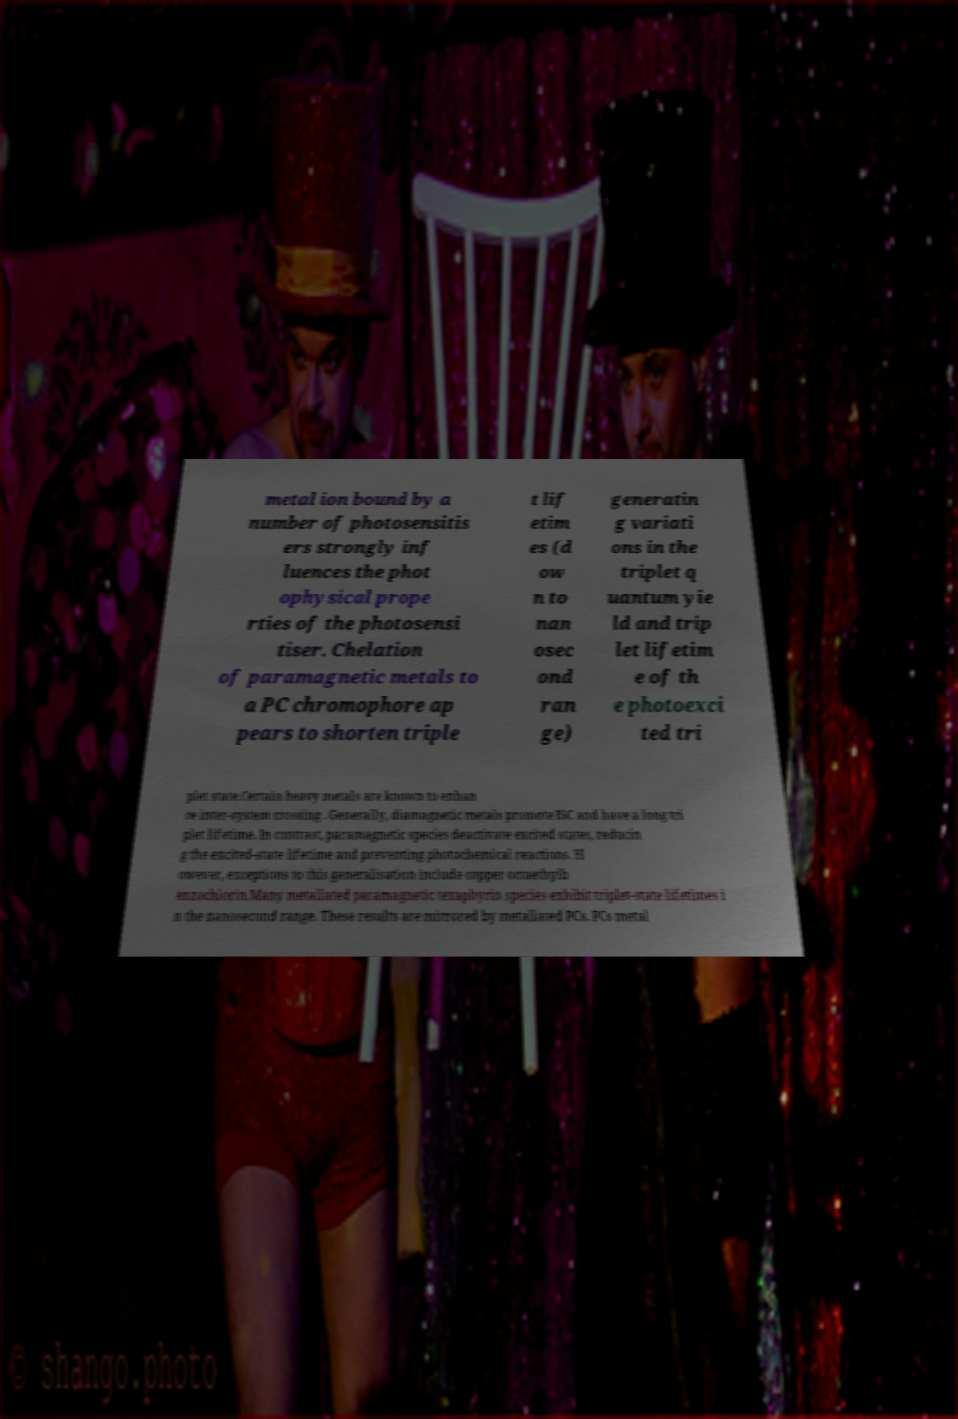For documentation purposes, I need the text within this image transcribed. Could you provide that? metal ion bound by a number of photosensitis ers strongly inf luences the phot ophysical prope rties of the photosensi tiser. Chelation of paramagnetic metals to a PC chromophore ap pears to shorten triple t lif etim es (d ow n to nan osec ond ran ge) generatin g variati ons in the triplet q uantum yie ld and trip let lifetim e of th e photoexci ted tri plet state.Certain heavy metals are known to enhan ce inter-system crossing . Generally, diamagnetic metals promote ISC and have a long tri plet lifetime. In contrast, paramagnetic species deactivate excited states, reducin g the excited-state lifetime and preventing photochemical reactions. H owever, exceptions to this generalisation include copper octaethylb enzochlorin.Many metallated paramagnetic texaphyrin species exhibit triplet-state lifetimes i n the nanosecond range. These results are mirrored by metallated PCs. PCs metal 